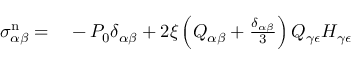Convert formula to latex. <formula><loc_0><loc_0><loc_500><loc_500>\begin{array} { r l } { \sigma _ { \alpha \beta } ^ { n } = } & - P _ { 0 } \delta _ { \alpha \beta } + 2 \xi \left ( Q _ { \alpha \beta } + \frac { \delta _ { \alpha \beta } } { 3 } \right ) Q _ { \gamma \epsilon } H _ { \gamma \epsilon } } \end{array}</formula> 